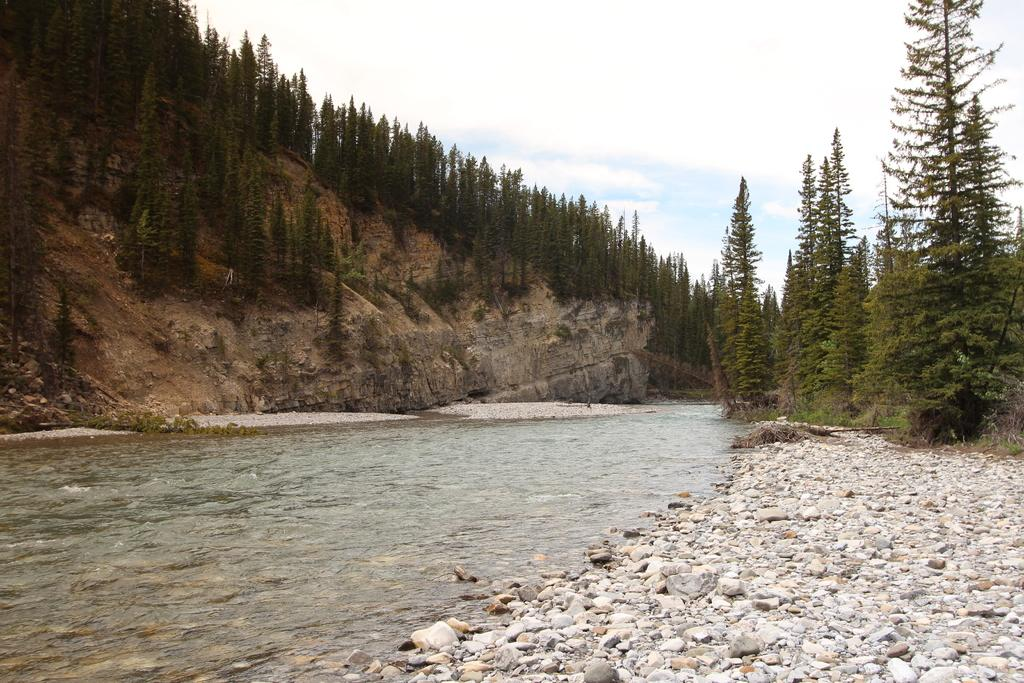What type of natural feature is the main subject of the image? There is a lake in the image. What can be seen in the background of the image? There is a group of trees and a mountain in the background of the image. What is visible above the trees and mountain in the image? The sky is visible in the background of the image. What type of plastic material is being used by the daughter in the image? There is no daughter or plastic material present in the image. 